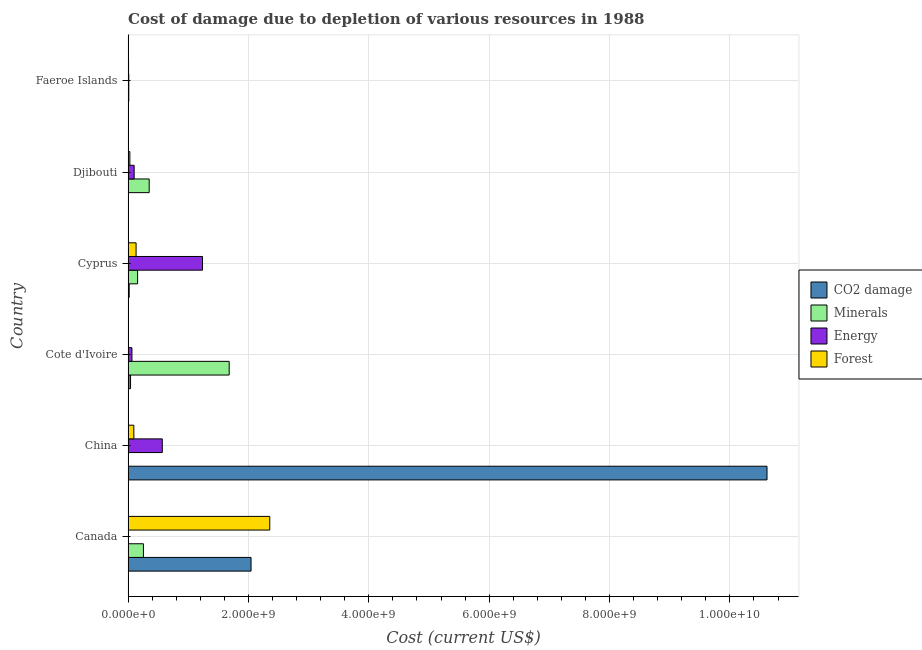How many bars are there on the 1st tick from the top?
Keep it short and to the point. 4. How many bars are there on the 5th tick from the bottom?
Your answer should be compact. 4. What is the label of the 1st group of bars from the top?
Ensure brevity in your answer.  Faeroe Islands. What is the cost of damage due to depletion of coal in Canada?
Give a very brief answer. 2.04e+09. Across all countries, what is the maximum cost of damage due to depletion of energy?
Offer a terse response. 1.24e+09. Across all countries, what is the minimum cost of damage due to depletion of forests?
Keep it short and to the point. 5.89e+04. In which country was the cost of damage due to depletion of minerals maximum?
Provide a succinct answer. Cote d'Ivoire. In which country was the cost of damage due to depletion of minerals minimum?
Your answer should be very brief. China. What is the total cost of damage due to depletion of minerals in the graph?
Provide a succinct answer. 2.46e+09. What is the difference between the cost of damage due to depletion of minerals in China and that in Cote d'Ivoire?
Ensure brevity in your answer.  -1.68e+09. What is the difference between the cost of damage due to depletion of minerals in Canada and the cost of damage due to depletion of forests in Cyprus?
Provide a succinct answer. 1.22e+08. What is the average cost of damage due to depletion of forests per country?
Give a very brief answer. 4.37e+08. What is the difference between the cost of damage due to depletion of coal and cost of damage due to depletion of energy in Djibouti?
Make the answer very short. -9.95e+07. In how many countries, is the cost of damage due to depletion of minerals greater than 5600000000 US$?
Make the answer very short. 0. What is the ratio of the cost of damage due to depletion of minerals in Cyprus to that in Faeroe Islands?
Ensure brevity in your answer.  13.56. What is the difference between the highest and the second highest cost of damage due to depletion of energy?
Give a very brief answer. 6.68e+08. What is the difference between the highest and the lowest cost of damage due to depletion of coal?
Keep it short and to the point. 1.06e+1. In how many countries, is the cost of damage due to depletion of minerals greater than the average cost of damage due to depletion of minerals taken over all countries?
Give a very brief answer. 1. Is the sum of the cost of damage due to depletion of forests in Canada and Cyprus greater than the maximum cost of damage due to depletion of energy across all countries?
Keep it short and to the point. Yes. What does the 1st bar from the top in China represents?
Provide a succinct answer. Forest. What does the 2nd bar from the bottom in Faeroe Islands represents?
Offer a terse response. Minerals. Is it the case that in every country, the sum of the cost of damage due to depletion of coal and cost of damage due to depletion of minerals is greater than the cost of damage due to depletion of energy?
Your response must be concise. No. Are all the bars in the graph horizontal?
Your answer should be very brief. Yes. Are the values on the major ticks of X-axis written in scientific E-notation?
Your response must be concise. Yes. Does the graph contain any zero values?
Give a very brief answer. No. Does the graph contain grids?
Your answer should be compact. Yes. Where does the legend appear in the graph?
Provide a succinct answer. Center right. How many legend labels are there?
Your answer should be very brief. 4. How are the legend labels stacked?
Offer a very short reply. Vertical. What is the title of the graph?
Provide a succinct answer. Cost of damage due to depletion of various resources in 1988 . What is the label or title of the X-axis?
Ensure brevity in your answer.  Cost (current US$). What is the Cost (current US$) of CO2 damage in Canada?
Provide a short and direct response. 2.04e+09. What is the Cost (current US$) in Minerals in Canada?
Your answer should be compact. 2.55e+08. What is the Cost (current US$) in Energy in Canada?
Your response must be concise. 4.08e+06. What is the Cost (current US$) of Forest in Canada?
Your response must be concise. 2.35e+09. What is the Cost (current US$) of CO2 damage in China?
Ensure brevity in your answer.  1.06e+1. What is the Cost (current US$) in Minerals in China?
Give a very brief answer. 1.52e+04. What is the Cost (current US$) in Energy in China?
Provide a succinct answer. 5.69e+08. What is the Cost (current US$) of Forest in China?
Offer a very short reply. 9.58e+07. What is the Cost (current US$) of CO2 damage in Cote d'Ivoire?
Your answer should be very brief. 4.10e+07. What is the Cost (current US$) in Minerals in Cote d'Ivoire?
Keep it short and to the point. 1.68e+09. What is the Cost (current US$) in Energy in Cote d'Ivoire?
Make the answer very short. 6.41e+07. What is the Cost (current US$) in Forest in Cote d'Ivoire?
Keep it short and to the point. 5.89e+04. What is the Cost (current US$) in CO2 damage in Cyprus?
Your response must be concise. 1.85e+07. What is the Cost (current US$) in Minerals in Cyprus?
Provide a succinct answer. 1.59e+08. What is the Cost (current US$) in Energy in Cyprus?
Offer a very short reply. 1.24e+09. What is the Cost (current US$) in Forest in Cyprus?
Your response must be concise. 1.33e+08. What is the Cost (current US$) of CO2 damage in Djibouti?
Ensure brevity in your answer.  1.59e+06. What is the Cost (current US$) of Minerals in Djibouti?
Provide a succinct answer. 3.51e+08. What is the Cost (current US$) of Energy in Djibouti?
Make the answer very short. 1.01e+08. What is the Cost (current US$) in Forest in Djibouti?
Keep it short and to the point. 2.96e+07. What is the Cost (current US$) of CO2 damage in Faeroe Islands?
Your response must be concise. 2.37e+06. What is the Cost (current US$) in Minerals in Faeroe Islands?
Your answer should be very brief. 1.17e+07. What is the Cost (current US$) in Energy in Faeroe Islands?
Keep it short and to the point. 1.18e+07. What is the Cost (current US$) in Forest in Faeroe Islands?
Provide a succinct answer. 8.30e+06. Across all countries, what is the maximum Cost (current US$) of CO2 damage?
Give a very brief answer. 1.06e+1. Across all countries, what is the maximum Cost (current US$) in Minerals?
Offer a terse response. 1.68e+09. Across all countries, what is the maximum Cost (current US$) of Energy?
Keep it short and to the point. 1.24e+09. Across all countries, what is the maximum Cost (current US$) of Forest?
Ensure brevity in your answer.  2.35e+09. Across all countries, what is the minimum Cost (current US$) in CO2 damage?
Provide a succinct answer. 1.59e+06. Across all countries, what is the minimum Cost (current US$) in Minerals?
Give a very brief answer. 1.52e+04. Across all countries, what is the minimum Cost (current US$) in Energy?
Provide a short and direct response. 4.08e+06. Across all countries, what is the minimum Cost (current US$) of Forest?
Your answer should be very brief. 5.89e+04. What is the total Cost (current US$) in CO2 damage in the graph?
Ensure brevity in your answer.  1.27e+1. What is the total Cost (current US$) of Minerals in the graph?
Offer a very short reply. 2.46e+09. What is the total Cost (current US$) in Energy in the graph?
Provide a succinct answer. 1.99e+09. What is the total Cost (current US$) of Forest in the graph?
Your response must be concise. 2.62e+09. What is the difference between the Cost (current US$) in CO2 damage in Canada and that in China?
Keep it short and to the point. -8.57e+09. What is the difference between the Cost (current US$) in Minerals in Canada and that in China?
Your answer should be very brief. 2.55e+08. What is the difference between the Cost (current US$) in Energy in Canada and that in China?
Your response must be concise. -5.65e+08. What is the difference between the Cost (current US$) in Forest in Canada and that in China?
Your answer should be compact. 2.26e+09. What is the difference between the Cost (current US$) of CO2 damage in Canada and that in Cote d'Ivoire?
Your answer should be very brief. 2.00e+09. What is the difference between the Cost (current US$) in Minerals in Canada and that in Cote d'Ivoire?
Give a very brief answer. -1.43e+09. What is the difference between the Cost (current US$) in Energy in Canada and that in Cote d'Ivoire?
Ensure brevity in your answer.  -6.00e+07. What is the difference between the Cost (current US$) of Forest in Canada and that in Cote d'Ivoire?
Provide a short and direct response. 2.35e+09. What is the difference between the Cost (current US$) in CO2 damage in Canada and that in Cyprus?
Offer a very short reply. 2.03e+09. What is the difference between the Cost (current US$) in Minerals in Canada and that in Cyprus?
Give a very brief answer. 9.67e+07. What is the difference between the Cost (current US$) of Energy in Canada and that in Cyprus?
Keep it short and to the point. -1.23e+09. What is the difference between the Cost (current US$) of Forest in Canada and that in Cyprus?
Provide a short and direct response. 2.22e+09. What is the difference between the Cost (current US$) in CO2 damage in Canada and that in Djibouti?
Provide a succinct answer. 2.04e+09. What is the difference between the Cost (current US$) in Minerals in Canada and that in Djibouti?
Provide a short and direct response. -9.56e+07. What is the difference between the Cost (current US$) of Energy in Canada and that in Djibouti?
Keep it short and to the point. -9.70e+07. What is the difference between the Cost (current US$) in Forest in Canada and that in Djibouti?
Keep it short and to the point. 2.32e+09. What is the difference between the Cost (current US$) in CO2 damage in Canada and that in Faeroe Islands?
Offer a very short reply. 2.04e+09. What is the difference between the Cost (current US$) of Minerals in Canada and that in Faeroe Islands?
Your answer should be compact. 2.44e+08. What is the difference between the Cost (current US$) of Energy in Canada and that in Faeroe Islands?
Ensure brevity in your answer.  -7.70e+06. What is the difference between the Cost (current US$) of Forest in Canada and that in Faeroe Islands?
Keep it short and to the point. 2.35e+09. What is the difference between the Cost (current US$) of CO2 damage in China and that in Cote d'Ivoire?
Offer a very short reply. 1.06e+1. What is the difference between the Cost (current US$) in Minerals in China and that in Cote d'Ivoire?
Provide a succinct answer. -1.68e+09. What is the difference between the Cost (current US$) in Energy in China and that in Cote d'Ivoire?
Provide a short and direct response. 5.05e+08. What is the difference between the Cost (current US$) in Forest in China and that in Cote d'Ivoire?
Your answer should be compact. 9.58e+07. What is the difference between the Cost (current US$) in CO2 damage in China and that in Cyprus?
Your answer should be very brief. 1.06e+1. What is the difference between the Cost (current US$) in Minerals in China and that in Cyprus?
Ensure brevity in your answer.  -1.58e+08. What is the difference between the Cost (current US$) in Energy in China and that in Cyprus?
Your answer should be very brief. -6.68e+08. What is the difference between the Cost (current US$) in Forest in China and that in Cyprus?
Make the answer very short. -3.71e+07. What is the difference between the Cost (current US$) of CO2 damage in China and that in Djibouti?
Your answer should be very brief. 1.06e+1. What is the difference between the Cost (current US$) of Minerals in China and that in Djibouti?
Provide a succinct answer. -3.51e+08. What is the difference between the Cost (current US$) of Energy in China and that in Djibouti?
Make the answer very short. 4.68e+08. What is the difference between the Cost (current US$) of Forest in China and that in Djibouti?
Provide a succinct answer. 6.62e+07. What is the difference between the Cost (current US$) of CO2 damage in China and that in Faeroe Islands?
Give a very brief answer. 1.06e+1. What is the difference between the Cost (current US$) in Minerals in China and that in Faeroe Islands?
Your answer should be very brief. -1.17e+07. What is the difference between the Cost (current US$) of Energy in China and that in Faeroe Islands?
Ensure brevity in your answer.  5.57e+08. What is the difference between the Cost (current US$) in Forest in China and that in Faeroe Islands?
Your answer should be compact. 8.75e+07. What is the difference between the Cost (current US$) in CO2 damage in Cote d'Ivoire and that in Cyprus?
Give a very brief answer. 2.25e+07. What is the difference between the Cost (current US$) of Minerals in Cote d'Ivoire and that in Cyprus?
Offer a very short reply. 1.52e+09. What is the difference between the Cost (current US$) of Energy in Cote d'Ivoire and that in Cyprus?
Your answer should be very brief. -1.17e+09. What is the difference between the Cost (current US$) in Forest in Cote d'Ivoire and that in Cyprus?
Offer a terse response. -1.33e+08. What is the difference between the Cost (current US$) of CO2 damage in Cote d'Ivoire and that in Djibouti?
Offer a terse response. 3.95e+07. What is the difference between the Cost (current US$) in Minerals in Cote d'Ivoire and that in Djibouti?
Your answer should be compact. 1.33e+09. What is the difference between the Cost (current US$) in Energy in Cote d'Ivoire and that in Djibouti?
Provide a short and direct response. -3.70e+07. What is the difference between the Cost (current US$) of Forest in Cote d'Ivoire and that in Djibouti?
Provide a short and direct response. -2.96e+07. What is the difference between the Cost (current US$) in CO2 damage in Cote d'Ivoire and that in Faeroe Islands?
Give a very brief answer. 3.87e+07. What is the difference between the Cost (current US$) of Minerals in Cote d'Ivoire and that in Faeroe Islands?
Give a very brief answer. 1.67e+09. What is the difference between the Cost (current US$) in Energy in Cote d'Ivoire and that in Faeroe Islands?
Make the answer very short. 5.23e+07. What is the difference between the Cost (current US$) of Forest in Cote d'Ivoire and that in Faeroe Islands?
Make the answer very short. -8.24e+06. What is the difference between the Cost (current US$) in CO2 damage in Cyprus and that in Djibouti?
Provide a succinct answer. 1.69e+07. What is the difference between the Cost (current US$) in Minerals in Cyprus and that in Djibouti?
Offer a terse response. -1.92e+08. What is the difference between the Cost (current US$) in Energy in Cyprus and that in Djibouti?
Your answer should be compact. 1.14e+09. What is the difference between the Cost (current US$) in Forest in Cyprus and that in Djibouti?
Ensure brevity in your answer.  1.03e+08. What is the difference between the Cost (current US$) of CO2 damage in Cyprus and that in Faeroe Islands?
Your answer should be compact. 1.61e+07. What is the difference between the Cost (current US$) in Minerals in Cyprus and that in Faeroe Islands?
Ensure brevity in your answer.  1.47e+08. What is the difference between the Cost (current US$) in Energy in Cyprus and that in Faeroe Islands?
Provide a short and direct response. 1.23e+09. What is the difference between the Cost (current US$) in Forest in Cyprus and that in Faeroe Islands?
Your response must be concise. 1.25e+08. What is the difference between the Cost (current US$) in CO2 damage in Djibouti and that in Faeroe Islands?
Make the answer very short. -7.72e+05. What is the difference between the Cost (current US$) in Minerals in Djibouti and that in Faeroe Islands?
Keep it short and to the point. 3.39e+08. What is the difference between the Cost (current US$) in Energy in Djibouti and that in Faeroe Islands?
Your answer should be compact. 8.93e+07. What is the difference between the Cost (current US$) in Forest in Djibouti and that in Faeroe Islands?
Your answer should be compact. 2.13e+07. What is the difference between the Cost (current US$) of CO2 damage in Canada and the Cost (current US$) of Minerals in China?
Give a very brief answer. 2.04e+09. What is the difference between the Cost (current US$) in CO2 damage in Canada and the Cost (current US$) in Energy in China?
Make the answer very short. 1.47e+09. What is the difference between the Cost (current US$) of CO2 damage in Canada and the Cost (current US$) of Forest in China?
Your response must be concise. 1.95e+09. What is the difference between the Cost (current US$) in Minerals in Canada and the Cost (current US$) in Energy in China?
Make the answer very short. -3.13e+08. What is the difference between the Cost (current US$) in Minerals in Canada and the Cost (current US$) in Forest in China?
Provide a short and direct response. 1.59e+08. What is the difference between the Cost (current US$) of Energy in Canada and the Cost (current US$) of Forest in China?
Give a very brief answer. -9.17e+07. What is the difference between the Cost (current US$) of CO2 damage in Canada and the Cost (current US$) of Minerals in Cote d'Ivoire?
Make the answer very short. 3.63e+08. What is the difference between the Cost (current US$) in CO2 damage in Canada and the Cost (current US$) in Energy in Cote d'Ivoire?
Keep it short and to the point. 1.98e+09. What is the difference between the Cost (current US$) in CO2 damage in Canada and the Cost (current US$) in Forest in Cote d'Ivoire?
Offer a terse response. 2.04e+09. What is the difference between the Cost (current US$) of Minerals in Canada and the Cost (current US$) of Energy in Cote d'Ivoire?
Your answer should be compact. 1.91e+08. What is the difference between the Cost (current US$) of Minerals in Canada and the Cost (current US$) of Forest in Cote d'Ivoire?
Your response must be concise. 2.55e+08. What is the difference between the Cost (current US$) of Energy in Canada and the Cost (current US$) of Forest in Cote d'Ivoire?
Make the answer very short. 4.02e+06. What is the difference between the Cost (current US$) of CO2 damage in Canada and the Cost (current US$) of Minerals in Cyprus?
Your response must be concise. 1.89e+09. What is the difference between the Cost (current US$) in CO2 damage in Canada and the Cost (current US$) in Energy in Cyprus?
Provide a short and direct response. 8.07e+08. What is the difference between the Cost (current US$) of CO2 damage in Canada and the Cost (current US$) of Forest in Cyprus?
Ensure brevity in your answer.  1.91e+09. What is the difference between the Cost (current US$) in Minerals in Canada and the Cost (current US$) in Energy in Cyprus?
Offer a very short reply. -9.82e+08. What is the difference between the Cost (current US$) in Minerals in Canada and the Cost (current US$) in Forest in Cyprus?
Provide a succinct answer. 1.22e+08. What is the difference between the Cost (current US$) in Energy in Canada and the Cost (current US$) in Forest in Cyprus?
Provide a succinct answer. -1.29e+08. What is the difference between the Cost (current US$) in CO2 damage in Canada and the Cost (current US$) in Minerals in Djibouti?
Ensure brevity in your answer.  1.69e+09. What is the difference between the Cost (current US$) in CO2 damage in Canada and the Cost (current US$) in Energy in Djibouti?
Offer a very short reply. 1.94e+09. What is the difference between the Cost (current US$) in CO2 damage in Canada and the Cost (current US$) in Forest in Djibouti?
Offer a very short reply. 2.01e+09. What is the difference between the Cost (current US$) of Minerals in Canada and the Cost (current US$) of Energy in Djibouti?
Keep it short and to the point. 1.54e+08. What is the difference between the Cost (current US$) of Minerals in Canada and the Cost (current US$) of Forest in Djibouti?
Your answer should be very brief. 2.26e+08. What is the difference between the Cost (current US$) of Energy in Canada and the Cost (current US$) of Forest in Djibouti?
Your answer should be very brief. -2.56e+07. What is the difference between the Cost (current US$) in CO2 damage in Canada and the Cost (current US$) in Minerals in Faeroe Islands?
Make the answer very short. 2.03e+09. What is the difference between the Cost (current US$) in CO2 damage in Canada and the Cost (current US$) in Energy in Faeroe Islands?
Your answer should be very brief. 2.03e+09. What is the difference between the Cost (current US$) in CO2 damage in Canada and the Cost (current US$) in Forest in Faeroe Islands?
Ensure brevity in your answer.  2.04e+09. What is the difference between the Cost (current US$) in Minerals in Canada and the Cost (current US$) in Energy in Faeroe Islands?
Provide a short and direct response. 2.43e+08. What is the difference between the Cost (current US$) in Minerals in Canada and the Cost (current US$) in Forest in Faeroe Islands?
Offer a very short reply. 2.47e+08. What is the difference between the Cost (current US$) of Energy in Canada and the Cost (current US$) of Forest in Faeroe Islands?
Keep it short and to the point. -4.22e+06. What is the difference between the Cost (current US$) in CO2 damage in China and the Cost (current US$) in Minerals in Cote d'Ivoire?
Your response must be concise. 8.94e+09. What is the difference between the Cost (current US$) in CO2 damage in China and the Cost (current US$) in Energy in Cote d'Ivoire?
Provide a succinct answer. 1.06e+1. What is the difference between the Cost (current US$) of CO2 damage in China and the Cost (current US$) of Forest in Cote d'Ivoire?
Ensure brevity in your answer.  1.06e+1. What is the difference between the Cost (current US$) in Minerals in China and the Cost (current US$) in Energy in Cote d'Ivoire?
Provide a succinct answer. -6.41e+07. What is the difference between the Cost (current US$) of Minerals in China and the Cost (current US$) of Forest in Cote d'Ivoire?
Offer a terse response. -4.37e+04. What is the difference between the Cost (current US$) of Energy in China and the Cost (current US$) of Forest in Cote d'Ivoire?
Keep it short and to the point. 5.69e+08. What is the difference between the Cost (current US$) of CO2 damage in China and the Cost (current US$) of Minerals in Cyprus?
Your answer should be compact. 1.05e+1. What is the difference between the Cost (current US$) of CO2 damage in China and the Cost (current US$) of Energy in Cyprus?
Your answer should be compact. 9.38e+09. What is the difference between the Cost (current US$) in CO2 damage in China and the Cost (current US$) in Forest in Cyprus?
Offer a terse response. 1.05e+1. What is the difference between the Cost (current US$) of Minerals in China and the Cost (current US$) of Energy in Cyprus?
Keep it short and to the point. -1.24e+09. What is the difference between the Cost (current US$) in Minerals in China and the Cost (current US$) in Forest in Cyprus?
Make the answer very short. -1.33e+08. What is the difference between the Cost (current US$) of Energy in China and the Cost (current US$) of Forest in Cyprus?
Offer a very short reply. 4.36e+08. What is the difference between the Cost (current US$) in CO2 damage in China and the Cost (current US$) in Minerals in Djibouti?
Ensure brevity in your answer.  1.03e+1. What is the difference between the Cost (current US$) in CO2 damage in China and the Cost (current US$) in Energy in Djibouti?
Give a very brief answer. 1.05e+1. What is the difference between the Cost (current US$) of CO2 damage in China and the Cost (current US$) of Forest in Djibouti?
Provide a succinct answer. 1.06e+1. What is the difference between the Cost (current US$) of Minerals in China and the Cost (current US$) of Energy in Djibouti?
Offer a very short reply. -1.01e+08. What is the difference between the Cost (current US$) in Minerals in China and the Cost (current US$) in Forest in Djibouti?
Provide a short and direct response. -2.96e+07. What is the difference between the Cost (current US$) of Energy in China and the Cost (current US$) of Forest in Djibouti?
Provide a succinct answer. 5.39e+08. What is the difference between the Cost (current US$) of CO2 damage in China and the Cost (current US$) of Minerals in Faeroe Islands?
Your answer should be very brief. 1.06e+1. What is the difference between the Cost (current US$) of CO2 damage in China and the Cost (current US$) of Energy in Faeroe Islands?
Provide a short and direct response. 1.06e+1. What is the difference between the Cost (current US$) in CO2 damage in China and the Cost (current US$) in Forest in Faeroe Islands?
Offer a terse response. 1.06e+1. What is the difference between the Cost (current US$) in Minerals in China and the Cost (current US$) in Energy in Faeroe Islands?
Make the answer very short. -1.18e+07. What is the difference between the Cost (current US$) of Minerals in China and the Cost (current US$) of Forest in Faeroe Islands?
Make the answer very short. -8.28e+06. What is the difference between the Cost (current US$) of Energy in China and the Cost (current US$) of Forest in Faeroe Islands?
Offer a terse response. 5.60e+08. What is the difference between the Cost (current US$) in CO2 damage in Cote d'Ivoire and the Cost (current US$) in Minerals in Cyprus?
Give a very brief answer. -1.17e+08. What is the difference between the Cost (current US$) in CO2 damage in Cote d'Ivoire and the Cost (current US$) in Energy in Cyprus?
Ensure brevity in your answer.  -1.20e+09. What is the difference between the Cost (current US$) in CO2 damage in Cote d'Ivoire and the Cost (current US$) in Forest in Cyprus?
Provide a short and direct response. -9.19e+07. What is the difference between the Cost (current US$) in Minerals in Cote d'Ivoire and the Cost (current US$) in Energy in Cyprus?
Your answer should be very brief. 4.43e+08. What is the difference between the Cost (current US$) in Minerals in Cote d'Ivoire and the Cost (current US$) in Forest in Cyprus?
Give a very brief answer. 1.55e+09. What is the difference between the Cost (current US$) of Energy in Cote d'Ivoire and the Cost (current US$) of Forest in Cyprus?
Keep it short and to the point. -6.88e+07. What is the difference between the Cost (current US$) of CO2 damage in Cote d'Ivoire and the Cost (current US$) of Minerals in Djibouti?
Your response must be concise. -3.10e+08. What is the difference between the Cost (current US$) in CO2 damage in Cote d'Ivoire and the Cost (current US$) in Energy in Djibouti?
Offer a very short reply. -6.01e+07. What is the difference between the Cost (current US$) in CO2 damage in Cote d'Ivoire and the Cost (current US$) in Forest in Djibouti?
Your response must be concise. 1.14e+07. What is the difference between the Cost (current US$) of Minerals in Cote d'Ivoire and the Cost (current US$) of Energy in Djibouti?
Ensure brevity in your answer.  1.58e+09. What is the difference between the Cost (current US$) of Minerals in Cote d'Ivoire and the Cost (current US$) of Forest in Djibouti?
Offer a terse response. 1.65e+09. What is the difference between the Cost (current US$) of Energy in Cote d'Ivoire and the Cost (current US$) of Forest in Djibouti?
Offer a terse response. 3.45e+07. What is the difference between the Cost (current US$) in CO2 damage in Cote d'Ivoire and the Cost (current US$) in Minerals in Faeroe Islands?
Provide a succinct answer. 2.94e+07. What is the difference between the Cost (current US$) in CO2 damage in Cote d'Ivoire and the Cost (current US$) in Energy in Faeroe Islands?
Make the answer very short. 2.93e+07. What is the difference between the Cost (current US$) in CO2 damage in Cote d'Ivoire and the Cost (current US$) in Forest in Faeroe Islands?
Your response must be concise. 3.27e+07. What is the difference between the Cost (current US$) of Minerals in Cote d'Ivoire and the Cost (current US$) of Energy in Faeroe Islands?
Provide a short and direct response. 1.67e+09. What is the difference between the Cost (current US$) in Minerals in Cote d'Ivoire and the Cost (current US$) in Forest in Faeroe Islands?
Offer a terse response. 1.67e+09. What is the difference between the Cost (current US$) of Energy in Cote d'Ivoire and the Cost (current US$) of Forest in Faeroe Islands?
Your response must be concise. 5.58e+07. What is the difference between the Cost (current US$) in CO2 damage in Cyprus and the Cost (current US$) in Minerals in Djibouti?
Provide a short and direct response. -3.32e+08. What is the difference between the Cost (current US$) in CO2 damage in Cyprus and the Cost (current US$) in Energy in Djibouti?
Offer a terse response. -8.26e+07. What is the difference between the Cost (current US$) of CO2 damage in Cyprus and the Cost (current US$) of Forest in Djibouti?
Your answer should be very brief. -1.11e+07. What is the difference between the Cost (current US$) in Minerals in Cyprus and the Cost (current US$) in Energy in Djibouti?
Keep it short and to the point. 5.74e+07. What is the difference between the Cost (current US$) in Minerals in Cyprus and the Cost (current US$) in Forest in Djibouti?
Keep it short and to the point. 1.29e+08. What is the difference between the Cost (current US$) of Energy in Cyprus and the Cost (current US$) of Forest in Djibouti?
Offer a very short reply. 1.21e+09. What is the difference between the Cost (current US$) of CO2 damage in Cyprus and the Cost (current US$) of Minerals in Faeroe Islands?
Provide a succinct answer. 6.81e+06. What is the difference between the Cost (current US$) in CO2 damage in Cyprus and the Cost (current US$) in Energy in Faeroe Islands?
Your answer should be very brief. 6.72e+06. What is the difference between the Cost (current US$) of CO2 damage in Cyprus and the Cost (current US$) of Forest in Faeroe Islands?
Keep it short and to the point. 1.02e+07. What is the difference between the Cost (current US$) of Minerals in Cyprus and the Cost (current US$) of Energy in Faeroe Islands?
Your answer should be compact. 1.47e+08. What is the difference between the Cost (current US$) of Minerals in Cyprus and the Cost (current US$) of Forest in Faeroe Islands?
Offer a terse response. 1.50e+08. What is the difference between the Cost (current US$) of Energy in Cyprus and the Cost (current US$) of Forest in Faeroe Islands?
Offer a very short reply. 1.23e+09. What is the difference between the Cost (current US$) in CO2 damage in Djibouti and the Cost (current US$) in Minerals in Faeroe Islands?
Give a very brief answer. -1.01e+07. What is the difference between the Cost (current US$) of CO2 damage in Djibouti and the Cost (current US$) of Energy in Faeroe Islands?
Your answer should be compact. -1.02e+07. What is the difference between the Cost (current US$) in CO2 damage in Djibouti and the Cost (current US$) in Forest in Faeroe Islands?
Make the answer very short. -6.70e+06. What is the difference between the Cost (current US$) of Minerals in Djibouti and the Cost (current US$) of Energy in Faeroe Islands?
Your response must be concise. 3.39e+08. What is the difference between the Cost (current US$) in Minerals in Djibouti and the Cost (current US$) in Forest in Faeroe Islands?
Offer a very short reply. 3.43e+08. What is the difference between the Cost (current US$) in Energy in Djibouti and the Cost (current US$) in Forest in Faeroe Islands?
Keep it short and to the point. 9.28e+07. What is the average Cost (current US$) in CO2 damage per country?
Offer a terse response. 2.12e+09. What is the average Cost (current US$) of Minerals per country?
Give a very brief answer. 4.09e+08. What is the average Cost (current US$) of Energy per country?
Your answer should be compact. 3.31e+08. What is the average Cost (current US$) of Forest per country?
Your answer should be compact. 4.37e+08. What is the difference between the Cost (current US$) of CO2 damage and Cost (current US$) of Minerals in Canada?
Offer a very short reply. 1.79e+09. What is the difference between the Cost (current US$) in CO2 damage and Cost (current US$) in Energy in Canada?
Keep it short and to the point. 2.04e+09. What is the difference between the Cost (current US$) of CO2 damage and Cost (current US$) of Forest in Canada?
Your answer should be compact. -3.11e+08. What is the difference between the Cost (current US$) in Minerals and Cost (current US$) in Energy in Canada?
Your response must be concise. 2.51e+08. What is the difference between the Cost (current US$) in Minerals and Cost (current US$) in Forest in Canada?
Your response must be concise. -2.10e+09. What is the difference between the Cost (current US$) in Energy and Cost (current US$) in Forest in Canada?
Your answer should be very brief. -2.35e+09. What is the difference between the Cost (current US$) of CO2 damage and Cost (current US$) of Minerals in China?
Offer a terse response. 1.06e+1. What is the difference between the Cost (current US$) in CO2 damage and Cost (current US$) in Energy in China?
Your answer should be very brief. 1.00e+1. What is the difference between the Cost (current US$) in CO2 damage and Cost (current US$) in Forest in China?
Provide a succinct answer. 1.05e+1. What is the difference between the Cost (current US$) of Minerals and Cost (current US$) of Energy in China?
Offer a very short reply. -5.69e+08. What is the difference between the Cost (current US$) in Minerals and Cost (current US$) in Forest in China?
Provide a short and direct response. -9.58e+07. What is the difference between the Cost (current US$) in Energy and Cost (current US$) in Forest in China?
Your answer should be compact. 4.73e+08. What is the difference between the Cost (current US$) of CO2 damage and Cost (current US$) of Minerals in Cote d'Ivoire?
Ensure brevity in your answer.  -1.64e+09. What is the difference between the Cost (current US$) in CO2 damage and Cost (current US$) in Energy in Cote d'Ivoire?
Your answer should be very brief. -2.31e+07. What is the difference between the Cost (current US$) of CO2 damage and Cost (current US$) of Forest in Cote d'Ivoire?
Give a very brief answer. 4.10e+07. What is the difference between the Cost (current US$) in Minerals and Cost (current US$) in Energy in Cote d'Ivoire?
Give a very brief answer. 1.62e+09. What is the difference between the Cost (current US$) in Minerals and Cost (current US$) in Forest in Cote d'Ivoire?
Provide a short and direct response. 1.68e+09. What is the difference between the Cost (current US$) of Energy and Cost (current US$) of Forest in Cote d'Ivoire?
Ensure brevity in your answer.  6.41e+07. What is the difference between the Cost (current US$) of CO2 damage and Cost (current US$) of Minerals in Cyprus?
Your answer should be very brief. -1.40e+08. What is the difference between the Cost (current US$) in CO2 damage and Cost (current US$) in Energy in Cyprus?
Give a very brief answer. -1.22e+09. What is the difference between the Cost (current US$) of CO2 damage and Cost (current US$) of Forest in Cyprus?
Give a very brief answer. -1.14e+08. What is the difference between the Cost (current US$) in Minerals and Cost (current US$) in Energy in Cyprus?
Offer a very short reply. -1.08e+09. What is the difference between the Cost (current US$) in Minerals and Cost (current US$) in Forest in Cyprus?
Your answer should be very brief. 2.56e+07. What is the difference between the Cost (current US$) of Energy and Cost (current US$) of Forest in Cyprus?
Give a very brief answer. 1.10e+09. What is the difference between the Cost (current US$) in CO2 damage and Cost (current US$) in Minerals in Djibouti?
Your answer should be very brief. -3.49e+08. What is the difference between the Cost (current US$) of CO2 damage and Cost (current US$) of Energy in Djibouti?
Your answer should be compact. -9.95e+07. What is the difference between the Cost (current US$) in CO2 damage and Cost (current US$) in Forest in Djibouti?
Offer a very short reply. -2.80e+07. What is the difference between the Cost (current US$) in Minerals and Cost (current US$) in Energy in Djibouti?
Offer a terse response. 2.50e+08. What is the difference between the Cost (current US$) in Minerals and Cost (current US$) in Forest in Djibouti?
Keep it short and to the point. 3.21e+08. What is the difference between the Cost (current US$) in Energy and Cost (current US$) in Forest in Djibouti?
Keep it short and to the point. 7.15e+07. What is the difference between the Cost (current US$) of CO2 damage and Cost (current US$) of Minerals in Faeroe Islands?
Your answer should be very brief. -9.33e+06. What is the difference between the Cost (current US$) of CO2 damage and Cost (current US$) of Energy in Faeroe Islands?
Give a very brief answer. -9.41e+06. What is the difference between the Cost (current US$) in CO2 damage and Cost (current US$) in Forest in Faeroe Islands?
Ensure brevity in your answer.  -5.93e+06. What is the difference between the Cost (current US$) of Minerals and Cost (current US$) of Energy in Faeroe Islands?
Make the answer very short. -8.70e+04. What is the difference between the Cost (current US$) in Minerals and Cost (current US$) in Forest in Faeroe Islands?
Ensure brevity in your answer.  3.39e+06. What is the difference between the Cost (current US$) of Energy and Cost (current US$) of Forest in Faeroe Islands?
Offer a very short reply. 3.48e+06. What is the ratio of the Cost (current US$) of CO2 damage in Canada to that in China?
Offer a very short reply. 0.19. What is the ratio of the Cost (current US$) of Minerals in Canada to that in China?
Make the answer very short. 1.68e+04. What is the ratio of the Cost (current US$) of Energy in Canada to that in China?
Your answer should be very brief. 0.01. What is the ratio of the Cost (current US$) of Forest in Canada to that in China?
Give a very brief answer. 24.57. What is the ratio of the Cost (current US$) in CO2 damage in Canada to that in Cote d'Ivoire?
Offer a very short reply. 49.79. What is the ratio of the Cost (current US$) of Minerals in Canada to that in Cote d'Ivoire?
Keep it short and to the point. 0.15. What is the ratio of the Cost (current US$) of Energy in Canada to that in Cote d'Ivoire?
Your answer should be very brief. 0.06. What is the ratio of the Cost (current US$) in Forest in Canada to that in Cote d'Ivoire?
Offer a very short reply. 4.00e+04. What is the ratio of the Cost (current US$) in CO2 damage in Canada to that in Cyprus?
Your response must be concise. 110.45. What is the ratio of the Cost (current US$) of Minerals in Canada to that in Cyprus?
Offer a very short reply. 1.61. What is the ratio of the Cost (current US$) of Energy in Canada to that in Cyprus?
Your answer should be very brief. 0. What is the ratio of the Cost (current US$) in Forest in Canada to that in Cyprus?
Provide a short and direct response. 17.71. What is the ratio of the Cost (current US$) of CO2 damage in Canada to that in Djibouti?
Provide a succinct answer. 1282.13. What is the ratio of the Cost (current US$) of Minerals in Canada to that in Djibouti?
Offer a very short reply. 0.73. What is the ratio of the Cost (current US$) of Energy in Canada to that in Djibouti?
Make the answer very short. 0.04. What is the ratio of the Cost (current US$) of Forest in Canada to that in Djibouti?
Your answer should be very brief. 79.45. What is the ratio of the Cost (current US$) in CO2 damage in Canada to that in Faeroe Islands?
Make the answer very short. 863.66. What is the ratio of the Cost (current US$) in Minerals in Canada to that in Faeroe Islands?
Offer a terse response. 21.83. What is the ratio of the Cost (current US$) in Energy in Canada to that in Faeroe Islands?
Offer a very short reply. 0.35. What is the ratio of the Cost (current US$) of Forest in Canada to that in Faeroe Islands?
Make the answer very short. 283.74. What is the ratio of the Cost (current US$) of CO2 damage in China to that in Cote d'Ivoire?
Your response must be concise. 258.67. What is the ratio of the Cost (current US$) of Minerals in China to that in Cote d'Ivoire?
Your answer should be compact. 0. What is the ratio of the Cost (current US$) of Energy in China to that in Cote d'Ivoire?
Make the answer very short. 8.87. What is the ratio of the Cost (current US$) in Forest in China to that in Cote d'Ivoire?
Your answer should be very brief. 1626.73. What is the ratio of the Cost (current US$) of CO2 damage in China to that in Cyprus?
Your response must be concise. 573.86. What is the ratio of the Cost (current US$) in Minerals in China to that in Cyprus?
Provide a succinct answer. 0. What is the ratio of the Cost (current US$) in Energy in China to that in Cyprus?
Ensure brevity in your answer.  0.46. What is the ratio of the Cost (current US$) of Forest in China to that in Cyprus?
Your answer should be very brief. 0.72. What is the ratio of the Cost (current US$) of CO2 damage in China to that in Djibouti?
Provide a short and direct response. 6661.54. What is the ratio of the Cost (current US$) in Energy in China to that in Djibouti?
Provide a succinct answer. 5.62. What is the ratio of the Cost (current US$) in Forest in China to that in Djibouti?
Your answer should be compact. 3.23. What is the ratio of the Cost (current US$) of CO2 damage in China to that in Faeroe Islands?
Keep it short and to the point. 4487.28. What is the ratio of the Cost (current US$) in Minerals in China to that in Faeroe Islands?
Keep it short and to the point. 0. What is the ratio of the Cost (current US$) in Energy in China to that in Faeroe Islands?
Offer a terse response. 48.27. What is the ratio of the Cost (current US$) of Forest in China to that in Faeroe Islands?
Make the answer very short. 11.55. What is the ratio of the Cost (current US$) in CO2 damage in Cote d'Ivoire to that in Cyprus?
Your answer should be compact. 2.22. What is the ratio of the Cost (current US$) in Minerals in Cote d'Ivoire to that in Cyprus?
Your answer should be very brief. 10.6. What is the ratio of the Cost (current US$) of Energy in Cote d'Ivoire to that in Cyprus?
Your answer should be very brief. 0.05. What is the ratio of the Cost (current US$) in Forest in Cote d'Ivoire to that in Cyprus?
Provide a short and direct response. 0. What is the ratio of the Cost (current US$) of CO2 damage in Cote d'Ivoire to that in Djibouti?
Your answer should be compact. 25.75. What is the ratio of the Cost (current US$) of Minerals in Cote d'Ivoire to that in Djibouti?
Your answer should be very brief. 4.79. What is the ratio of the Cost (current US$) of Energy in Cote d'Ivoire to that in Djibouti?
Your answer should be very brief. 0.63. What is the ratio of the Cost (current US$) in Forest in Cote d'Ivoire to that in Djibouti?
Your answer should be very brief. 0. What is the ratio of the Cost (current US$) of CO2 damage in Cote d'Ivoire to that in Faeroe Islands?
Make the answer very short. 17.35. What is the ratio of the Cost (current US$) of Minerals in Cote d'Ivoire to that in Faeroe Islands?
Offer a very short reply. 143.71. What is the ratio of the Cost (current US$) in Energy in Cote d'Ivoire to that in Faeroe Islands?
Keep it short and to the point. 5.44. What is the ratio of the Cost (current US$) in Forest in Cote d'Ivoire to that in Faeroe Islands?
Your answer should be compact. 0.01. What is the ratio of the Cost (current US$) of CO2 damage in Cyprus to that in Djibouti?
Provide a short and direct response. 11.61. What is the ratio of the Cost (current US$) in Minerals in Cyprus to that in Djibouti?
Your answer should be compact. 0.45. What is the ratio of the Cost (current US$) in Energy in Cyprus to that in Djibouti?
Your answer should be very brief. 12.23. What is the ratio of the Cost (current US$) in Forest in Cyprus to that in Djibouti?
Ensure brevity in your answer.  4.49. What is the ratio of the Cost (current US$) of CO2 damage in Cyprus to that in Faeroe Islands?
Provide a short and direct response. 7.82. What is the ratio of the Cost (current US$) of Minerals in Cyprus to that in Faeroe Islands?
Ensure brevity in your answer.  13.56. What is the ratio of the Cost (current US$) of Energy in Cyprus to that in Faeroe Islands?
Give a very brief answer. 105. What is the ratio of the Cost (current US$) in Forest in Cyprus to that in Faeroe Islands?
Your answer should be compact. 16.02. What is the ratio of the Cost (current US$) in CO2 damage in Djibouti to that in Faeroe Islands?
Make the answer very short. 0.67. What is the ratio of the Cost (current US$) in Minerals in Djibouti to that in Faeroe Islands?
Make the answer very short. 30.01. What is the ratio of the Cost (current US$) of Energy in Djibouti to that in Faeroe Islands?
Provide a short and direct response. 8.58. What is the ratio of the Cost (current US$) in Forest in Djibouti to that in Faeroe Islands?
Give a very brief answer. 3.57. What is the difference between the highest and the second highest Cost (current US$) in CO2 damage?
Offer a terse response. 8.57e+09. What is the difference between the highest and the second highest Cost (current US$) of Minerals?
Provide a succinct answer. 1.33e+09. What is the difference between the highest and the second highest Cost (current US$) of Energy?
Make the answer very short. 6.68e+08. What is the difference between the highest and the second highest Cost (current US$) in Forest?
Offer a very short reply. 2.22e+09. What is the difference between the highest and the lowest Cost (current US$) of CO2 damage?
Make the answer very short. 1.06e+1. What is the difference between the highest and the lowest Cost (current US$) in Minerals?
Make the answer very short. 1.68e+09. What is the difference between the highest and the lowest Cost (current US$) of Energy?
Give a very brief answer. 1.23e+09. What is the difference between the highest and the lowest Cost (current US$) in Forest?
Provide a succinct answer. 2.35e+09. 